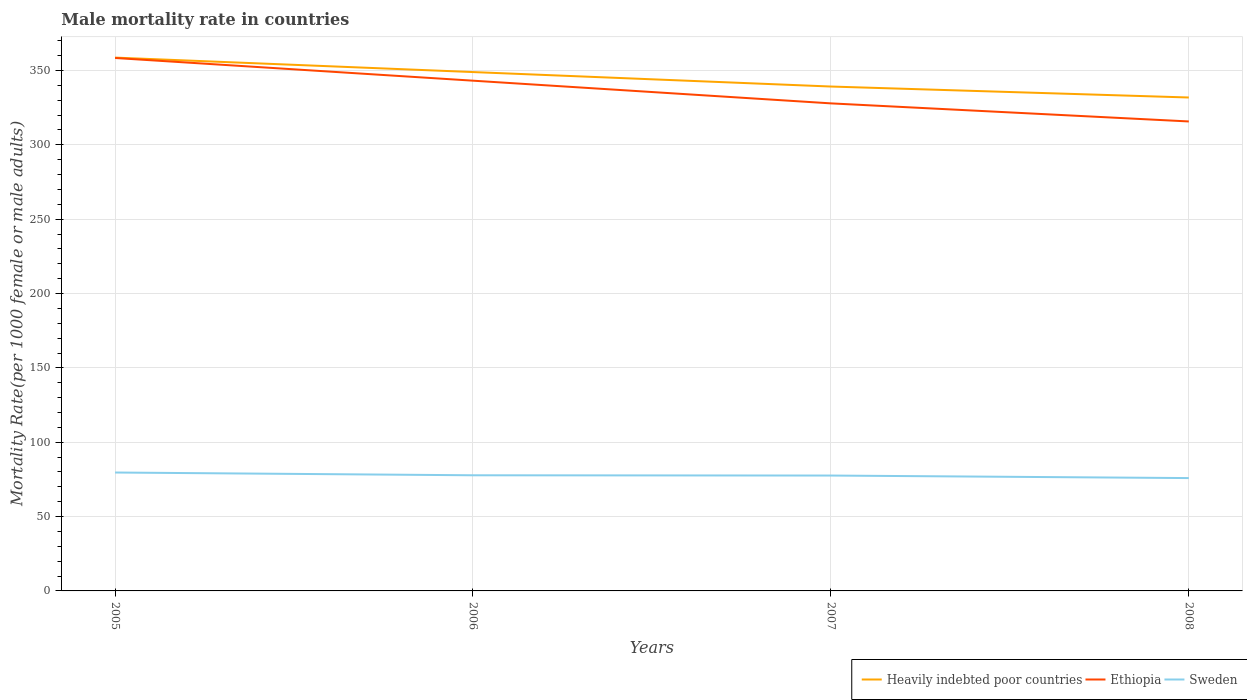Does the line corresponding to Sweden intersect with the line corresponding to Ethiopia?
Your response must be concise. No. Across all years, what is the maximum male mortality rate in Sweden?
Provide a short and direct response. 75.89. In which year was the male mortality rate in Ethiopia maximum?
Offer a terse response. 2008. What is the total male mortality rate in Ethiopia in the graph?
Provide a short and direct response. 15.27. What is the difference between the highest and the second highest male mortality rate in Sweden?
Make the answer very short. 3.74. Is the male mortality rate in Ethiopia strictly greater than the male mortality rate in Heavily indebted poor countries over the years?
Provide a succinct answer. Yes. What is the difference between two consecutive major ticks on the Y-axis?
Provide a succinct answer. 50. Does the graph contain any zero values?
Offer a terse response. No. How many legend labels are there?
Make the answer very short. 3. What is the title of the graph?
Offer a very short reply. Male mortality rate in countries. What is the label or title of the X-axis?
Ensure brevity in your answer.  Years. What is the label or title of the Y-axis?
Offer a very short reply. Mortality Rate(per 1000 female or male adults). What is the Mortality Rate(per 1000 female or male adults) of Heavily indebted poor countries in 2005?
Ensure brevity in your answer.  358.68. What is the Mortality Rate(per 1000 female or male adults) of Ethiopia in 2005?
Make the answer very short. 358.43. What is the Mortality Rate(per 1000 female or male adults) of Sweden in 2005?
Keep it short and to the point. 79.63. What is the Mortality Rate(per 1000 female or male adults) of Heavily indebted poor countries in 2006?
Ensure brevity in your answer.  348.95. What is the Mortality Rate(per 1000 female or male adults) in Ethiopia in 2006?
Make the answer very short. 343.16. What is the Mortality Rate(per 1000 female or male adults) in Sweden in 2006?
Make the answer very short. 77.77. What is the Mortality Rate(per 1000 female or male adults) of Heavily indebted poor countries in 2007?
Offer a terse response. 339.22. What is the Mortality Rate(per 1000 female or male adults) in Ethiopia in 2007?
Keep it short and to the point. 327.89. What is the Mortality Rate(per 1000 female or male adults) of Sweden in 2007?
Give a very brief answer. 77.59. What is the Mortality Rate(per 1000 female or male adults) of Heavily indebted poor countries in 2008?
Offer a very short reply. 331.85. What is the Mortality Rate(per 1000 female or male adults) in Ethiopia in 2008?
Offer a terse response. 315.74. What is the Mortality Rate(per 1000 female or male adults) in Sweden in 2008?
Keep it short and to the point. 75.89. Across all years, what is the maximum Mortality Rate(per 1000 female or male adults) of Heavily indebted poor countries?
Offer a terse response. 358.68. Across all years, what is the maximum Mortality Rate(per 1000 female or male adults) of Ethiopia?
Give a very brief answer. 358.43. Across all years, what is the maximum Mortality Rate(per 1000 female or male adults) of Sweden?
Offer a terse response. 79.63. Across all years, what is the minimum Mortality Rate(per 1000 female or male adults) in Heavily indebted poor countries?
Offer a very short reply. 331.85. Across all years, what is the minimum Mortality Rate(per 1000 female or male adults) in Ethiopia?
Your response must be concise. 315.74. Across all years, what is the minimum Mortality Rate(per 1000 female or male adults) in Sweden?
Your answer should be very brief. 75.89. What is the total Mortality Rate(per 1000 female or male adults) of Heavily indebted poor countries in the graph?
Offer a terse response. 1378.71. What is the total Mortality Rate(per 1000 female or male adults) of Ethiopia in the graph?
Your response must be concise. 1345.22. What is the total Mortality Rate(per 1000 female or male adults) of Sweden in the graph?
Offer a very short reply. 310.89. What is the difference between the Mortality Rate(per 1000 female or male adults) of Heavily indebted poor countries in 2005 and that in 2006?
Provide a succinct answer. 9.73. What is the difference between the Mortality Rate(per 1000 female or male adults) of Ethiopia in 2005 and that in 2006?
Ensure brevity in your answer.  15.27. What is the difference between the Mortality Rate(per 1000 female or male adults) of Sweden in 2005 and that in 2006?
Your answer should be compact. 1.86. What is the difference between the Mortality Rate(per 1000 female or male adults) of Heavily indebted poor countries in 2005 and that in 2007?
Offer a terse response. 19.46. What is the difference between the Mortality Rate(per 1000 female or male adults) of Ethiopia in 2005 and that in 2007?
Make the answer very short. 30.53. What is the difference between the Mortality Rate(per 1000 female or male adults) of Sweden in 2005 and that in 2007?
Provide a succinct answer. 2.04. What is the difference between the Mortality Rate(per 1000 female or male adults) in Heavily indebted poor countries in 2005 and that in 2008?
Make the answer very short. 26.84. What is the difference between the Mortality Rate(per 1000 female or male adults) of Ethiopia in 2005 and that in 2008?
Keep it short and to the point. 42.69. What is the difference between the Mortality Rate(per 1000 female or male adults) in Sweden in 2005 and that in 2008?
Ensure brevity in your answer.  3.74. What is the difference between the Mortality Rate(per 1000 female or male adults) in Heavily indebted poor countries in 2006 and that in 2007?
Offer a very short reply. 9.73. What is the difference between the Mortality Rate(per 1000 female or male adults) in Ethiopia in 2006 and that in 2007?
Your response must be concise. 15.27. What is the difference between the Mortality Rate(per 1000 female or male adults) in Sweden in 2006 and that in 2007?
Provide a short and direct response. 0.18. What is the difference between the Mortality Rate(per 1000 female or male adults) of Heavily indebted poor countries in 2006 and that in 2008?
Offer a terse response. 17.11. What is the difference between the Mortality Rate(per 1000 female or male adults) in Ethiopia in 2006 and that in 2008?
Your answer should be compact. 27.43. What is the difference between the Mortality Rate(per 1000 female or male adults) of Sweden in 2006 and that in 2008?
Your answer should be very brief. 1.88. What is the difference between the Mortality Rate(per 1000 female or male adults) in Heavily indebted poor countries in 2007 and that in 2008?
Give a very brief answer. 7.38. What is the difference between the Mortality Rate(per 1000 female or male adults) in Ethiopia in 2007 and that in 2008?
Make the answer very short. 12.16. What is the difference between the Mortality Rate(per 1000 female or male adults) of Sweden in 2007 and that in 2008?
Your answer should be compact. 1.7. What is the difference between the Mortality Rate(per 1000 female or male adults) of Heavily indebted poor countries in 2005 and the Mortality Rate(per 1000 female or male adults) of Ethiopia in 2006?
Your response must be concise. 15.52. What is the difference between the Mortality Rate(per 1000 female or male adults) of Heavily indebted poor countries in 2005 and the Mortality Rate(per 1000 female or male adults) of Sweden in 2006?
Offer a very short reply. 280.91. What is the difference between the Mortality Rate(per 1000 female or male adults) of Ethiopia in 2005 and the Mortality Rate(per 1000 female or male adults) of Sweden in 2006?
Give a very brief answer. 280.65. What is the difference between the Mortality Rate(per 1000 female or male adults) in Heavily indebted poor countries in 2005 and the Mortality Rate(per 1000 female or male adults) in Ethiopia in 2007?
Offer a terse response. 30.79. What is the difference between the Mortality Rate(per 1000 female or male adults) of Heavily indebted poor countries in 2005 and the Mortality Rate(per 1000 female or male adults) of Sweden in 2007?
Make the answer very short. 281.09. What is the difference between the Mortality Rate(per 1000 female or male adults) of Ethiopia in 2005 and the Mortality Rate(per 1000 female or male adults) of Sweden in 2007?
Your answer should be very brief. 280.84. What is the difference between the Mortality Rate(per 1000 female or male adults) of Heavily indebted poor countries in 2005 and the Mortality Rate(per 1000 female or male adults) of Ethiopia in 2008?
Give a very brief answer. 42.95. What is the difference between the Mortality Rate(per 1000 female or male adults) in Heavily indebted poor countries in 2005 and the Mortality Rate(per 1000 female or male adults) in Sweden in 2008?
Your response must be concise. 282.79. What is the difference between the Mortality Rate(per 1000 female or male adults) in Ethiopia in 2005 and the Mortality Rate(per 1000 female or male adults) in Sweden in 2008?
Your answer should be compact. 282.53. What is the difference between the Mortality Rate(per 1000 female or male adults) of Heavily indebted poor countries in 2006 and the Mortality Rate(per 1000 female or male adults) of Ethiopia in 2007?
Offer a terse response. 21.06. What is the difference between the Mortality Rate(per 1000 female or male adults) in Heavily indebted poor countries in 2006 and the Mortality Rate(per 1000 female or male adults) in Sweden in 2007?
Your answer should be compact. 271.36. What is the difference between the Mortality Rate(per 1000 female or male adults) of Ethiopia in 2006 and the Mortality Rate(per 1000 female or male adults) of Sweden in 2007?
Give a very brief answer. 265.57. What is the difference between the Mortality Rate(per 1000 female or male adults) of Heavily indebted poor countries in 2006 and the Mortality Rate(per 1000 female or male adults) of Ethiopia in 2008?
Ensure brevity in your answer.  33.22. What is the difference between the Mortality Rate(per 1000 female or male adults) of Heavily indebted poor countries in 2006 and the Mortality Rate(per 1000 female or male adults) of Sweden in 2008?
Your answer should be compact. 273.06. What is the difference between the Mortality Rate(per 1000 female or male adults) in Ethiopia in 2006 and the Mortality Rate(per 1000 female or male adults) in Sweden in 2008?
Offer a terse response. 267.27. What is the difference between the Mortality Rate(per 1000 female or male adults) in Heavily indebted poor countries in 2007 and the Mortality Rate(per 1000 female or male adults) in Ethiopia in 2008?
Your answer should be very brief. 23.49. What is the difference between the Mortality Rate(per 1000 female or male adults) in Heavily indebted poor countries in 2007 and the Mortality Rate(per 1000 female or male adults) in Sweden in 2008?
Your answer should be compact. 263.33. What is the difference between the Mortality Rate(per 1000 female or male adults) in Ethiopia in 2007 and the Mortality Rate(per 1000 female or male adults) in Sweden in 2008?
Make the answer very short. 252. What is the average Mortality Rate(per 1000 female or male adults) in Heavily indebted poor countries per year?
Your response must be concise. 344.68. What is the average Mortality Rate(per 1000 female or male adults) of Ethiopia per year?
Make the answer very short. 336.3. What is the average Mortality Rate(per 1000 female or male adults) in Sweden per year?
Provide a succinct answer. 77.72. In the year 2005, what is the difference between the Mortality Rate(per 1000 female or male adults) of Heavily indebted poor countries and Mortality Rate(per 1000 female or male adults) of Ethiopia?
Ensure brevity in your answer.  0.26. In the year 2005, what is the difference between the Mortality Rate(per 1000 female or male adults) of Heavily indebted poor countries and Mortality Rate(per 1000 female or male adults) of Sweden?
Make the answer very short. 279.05. In the year 2005, what is the difference between the Mortality Rate(per 1000 female or male adults) of Ethiopia and Mortality Rate(per 1000 female or male adults) of Sweden?
Your response must be concise. 278.79. In the year 2006, what is the difference between the Mortality Rate(per 1000 female or male adults) of Heavily indebted poor countries and Mortality Rate(per 1000 female or male adults) of Ethiopia?
Your answer should be compact. 5.79. In the year 2006, what is the difference between the Mortality Rate(per 1000 female or male adults) of Heavily indebted poor countries and Mortality Rate(per 1000 female or male adults) of Sweden?
Your answer should be compact. 271.18. In the year 2006, what is the difference between the Mortality Rate(per 1000 female or male adults) in Ethiopia and Mortality Rate(per 1000 female or male adults) in Sweden?
Provide a short and direct response. 265.39. In the year 2007, what is the difference between the Mortality Rate(per 1000 female or male adults) of Heavily indebted poor countries and Mortality Rate(per 1000 female or male adults) of Ethiopia?
Provide a short and direct response. 11.33. In the year 2007, what is the difference between the Mortality Rate(per 1000 female or male adults) of Heavily indebted poor countries and Mortality Rate(per 1000 female or male adults) of Sweden?
Provide a succinct answer. 261.63. In the year 2007, what is the difference between the Mortality Rate(per 1000 female or male adults) of Ethiopia and Mortality Rate(per 1000 female or male adults) of Sweden?
Make the answer very short. 250.31. In the year 2008, what is the difference between the Mortality Rate(per 1000 female or male adults) in Heavily indebted poor countries and Mortality Rate(per 1000 female or male adults) in Ethiopia?
Offer a very short reply. 16.11. In the year 2008, what is the difference between the Mortality Rate(per 1000 female or male adults) in Heavily indebted poor countries and Mortality Rate(per 1000 female or male adults) in Sweden?
Keep it short and to the point. 255.95. In the year 2008, what is the difference between the Mortality Rate(per 1000 female or male adults) of Ethiopia and Mortality Rate(per 1000 female or male adults) of Sweden?
Your answer should be very brief. 239.84. What is the ratio of the Mortality Rate(per 1000 female or male adults) in Heavily indebted poor countries in 2005 to that in 2006?
Provide a short and direct response. 1.03. What is the ratio of the Mortality Rate(per 1000 female or male adults) in Ethiopia in 2005 to that in 2006?
Provide a succinct answer. 1.04. What is the ratio of the Mortality Rate(per 1000 female or male adults) in Sweden in 2005 to that in 2006?
Your answer should be compact. 1.02. What is the ratio of the Mortality Rate(per 1000 female or male adults) of Heavily indebted poor countries in 2005 to that in 2007?
Offer a very short reply. 1.06. What is the ratio of the Mortality Rate(per 1000 female or male adults) in Ethiopia in 2005 to that in 2007?
Keep it short and to the point. 1.09. What is the ratio of the Mortality Rate(per 1000 female or male adults) of Sweden in 2005 to that in 2007?
Offer a very short reply. 1.03. What is the ratio of the Mortality Rate(per 1000 female or male adults) in Heavily indebted poor countries in 2005 to that in 2008?
Make the answer very short. 1.08. What is the ratio of the Mortality Rate(per 1000 female or male adults) in Ethiopia in 2005 to that in 2008?
Provide a succinct answer. 1.14. What is the ratio of the Mortality Rate(per 1000 female or male adults) in Sweden in 2005 to that in 2008?
Provide a short and direct response. 1.05. What is the ratio of the Mortality Rate(per 1000 female or male adults) of Heavily indebted poor countries in 2006 to that in 2007?
Keep it short and to the point. 1.03. What is the ratio of the Mortality Rate(per 1000 female or male adults) in Ethiopia in 2006 to that in 2007?
Offer a very short reply. 1.05. What is the ratio of the Mortality Rate(per 1000 female or male adults) of Sweden in 2006 to that in 2007?
Make the answer very short. 1. What is the ratio of the Mortality Rate(per 1000 female or male adults) of Heavily indebted poor countries in 2006 to that in 2008?
Provide a short and direct response. 1.05. What is the ratio of the Mortality Rate(per 1000 female or male adults) of Ethiopia in 2006 to that in 2008?
Provide a short and direct response. 1.09. What is the ratio of the Mortality Rate(per 1000 female or male adults) of Sweden in 2006 to that in 2008?
Offer a very short reply. 1.02. What is the ratio of the Mortality Rate(per 1000 female or male adults) of Heavily indebted poor countries in 2007 to that in 2008?
Your response must be concise. 1.02. What is the ratio of the Mortality Rate(per 1000 female or male adults) of Sweden in 2007 to that in 2008?
Offer a terse response. 1.02. What is the difference between the highest and the second highest Mortality Rate(per 1000 female or male adults) of Heavily indebted poor countries?
Keep it short and to the point. 9.73. What is the difference between the highest and the second highest Mortality Rate(per 1000 female or male adults) in Ethiopia?
Offer a very short reply. 15.27. What is the difference between the highest and the second highest Mortality Rate(per 1000 female or male adults) of Sweden?
Provide a short and direct response. 1.86. What is the difference between the highest and the lowest Mortality Rate(per 1000 female or male adults) of Heavily indebted poor countries?
Ensure brevity in your answer.  26.84. What is the difference between the highest and the lowest Mortality Rate(per 1000 female or male adults) of Ethiopia?
Your answer should be very brief. 42.69. What is the difference between the highest and the lowest Mortality Rate(per 1000 female or male adults) in Sweden?
Keep it short and to the point. 3.74. 